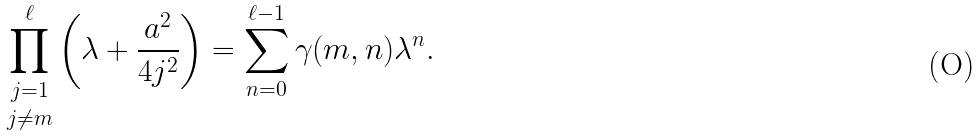Convert formula to latex. <formula><loc_0><loc_0><loc_500><loc_500>\underset { j \ne m } { \prod ^ { \ell } _ { j = 1 } } \left ( \lambda + \frac { a ^ { 2 } } { 4 j ^ { 2 } } \right ) = \sum ^ { \ell - 1 } _ { n = 0 } \gamma ( m , n ) \lambda ^ { n } .</formula> 